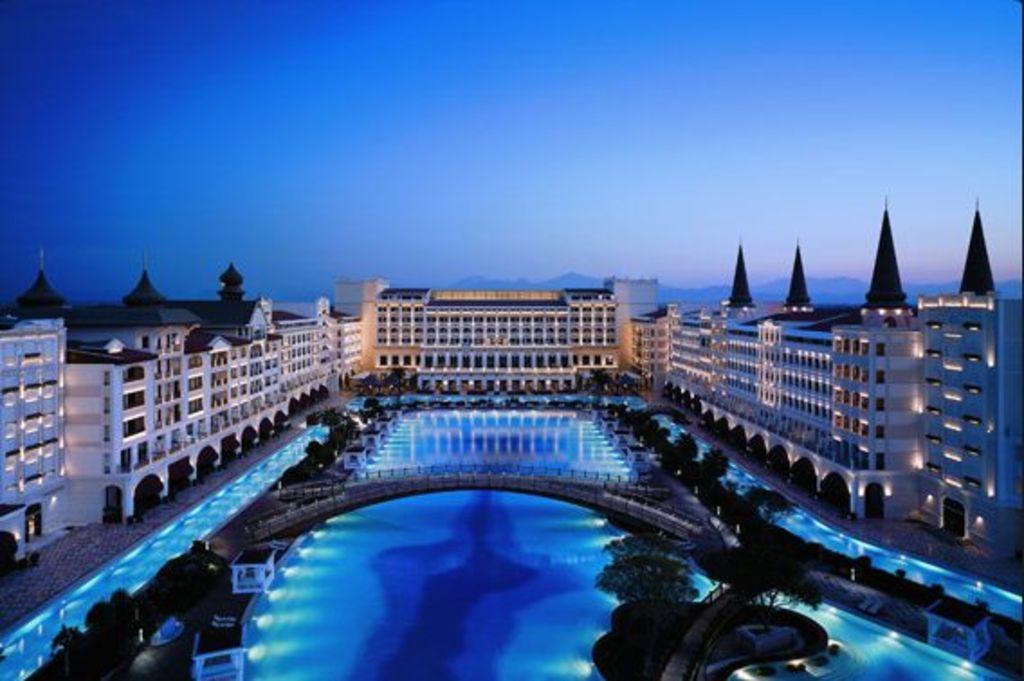Please provide a concise description of this image. In this image there are buildings. In the center there is a big swimming pool. There is a bridge on the swimming pool. Beside the pool there are plants. In the background there are mountains. At the top there is the sky. 